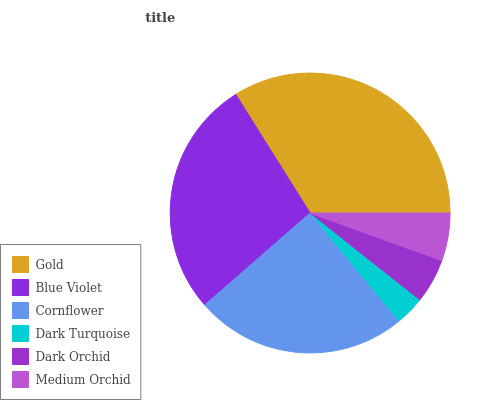Is Dark Turquoise the minimum?
Answer yes or no. Yes. Is Gold the maximum?
Answer yes or no. Yes. Is Blue Violet the minimum?
Answer yes or no. No. Is Blue Violet the maximum?
Answer yes or no. No. Is Gold greater than Blue Violet?
Answer yes or no. Yes. Is Blue Violet less than Gold?
Answer yes or no. Yes. Is Blue Violet greater than Gold?
Answer yes or no. No. Is Gold less than Blue Violet?
Answer yes or no. No. Is Cornflower the high median?
Answer yes or no. Yes. Is Medium Orchid the low median?
Answer yes or no. Yes. Is Gold the high median?
Answer yes or no. No. Is Dark Orchid the low median?
Answer yes or no. No. 